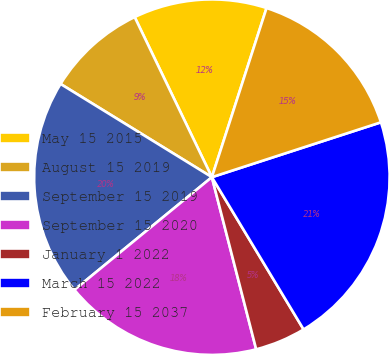Convert chart. <chart><loc_0><loc_0><loc_500><loc_500><pie_chart><fcel>May 15 2015<fcel>August 15 2019<fcel>September 15 2019<fcel>September 15 2020<fcel>January 1 2022<fcel>March 15 2022<fcel>February 15 2037<nl><fcel>12.13%<fcel>9.06%<fcel>19.72%<fcel>18.08%<fcel>4.62%<fcel>21.37%<fcel>15.03%<nl></chart> 